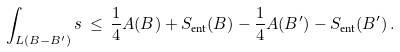Convert formula to latex. <formula><loc_0><loc_0><loc_500><loc_500>\int _ { L ( B - B ^ { \prime } ) } s \, \leq \, \frac { 1 } { 4 } A ( B ) + S _ { \text {ent} } ( B ) - \frac { 1 } { 4 } A ( B ^ { \prime } ) - S _ { \text {ent} } ( B ^ { \prime } ) \, .</formula> 